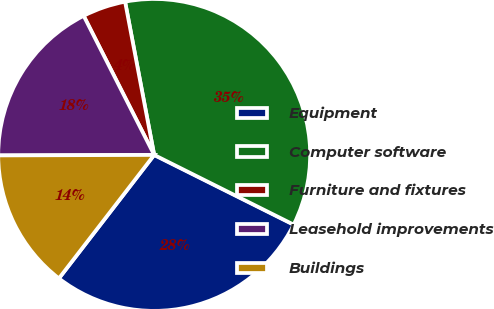Convert chart to OTSL. <chart><loc_0><loc_0><loc_500><loc_500><pie_chart><fcel>Equipment<fcel>Computer software<fcel>Furniture and fixtures<fcel>Leasehold improvements<fcel>Buildings<nl><fcel>28.08%<fcel>35.36%<fcel>4.48%<fcel>17.58%<fcel>14.49%<nl></chart> 